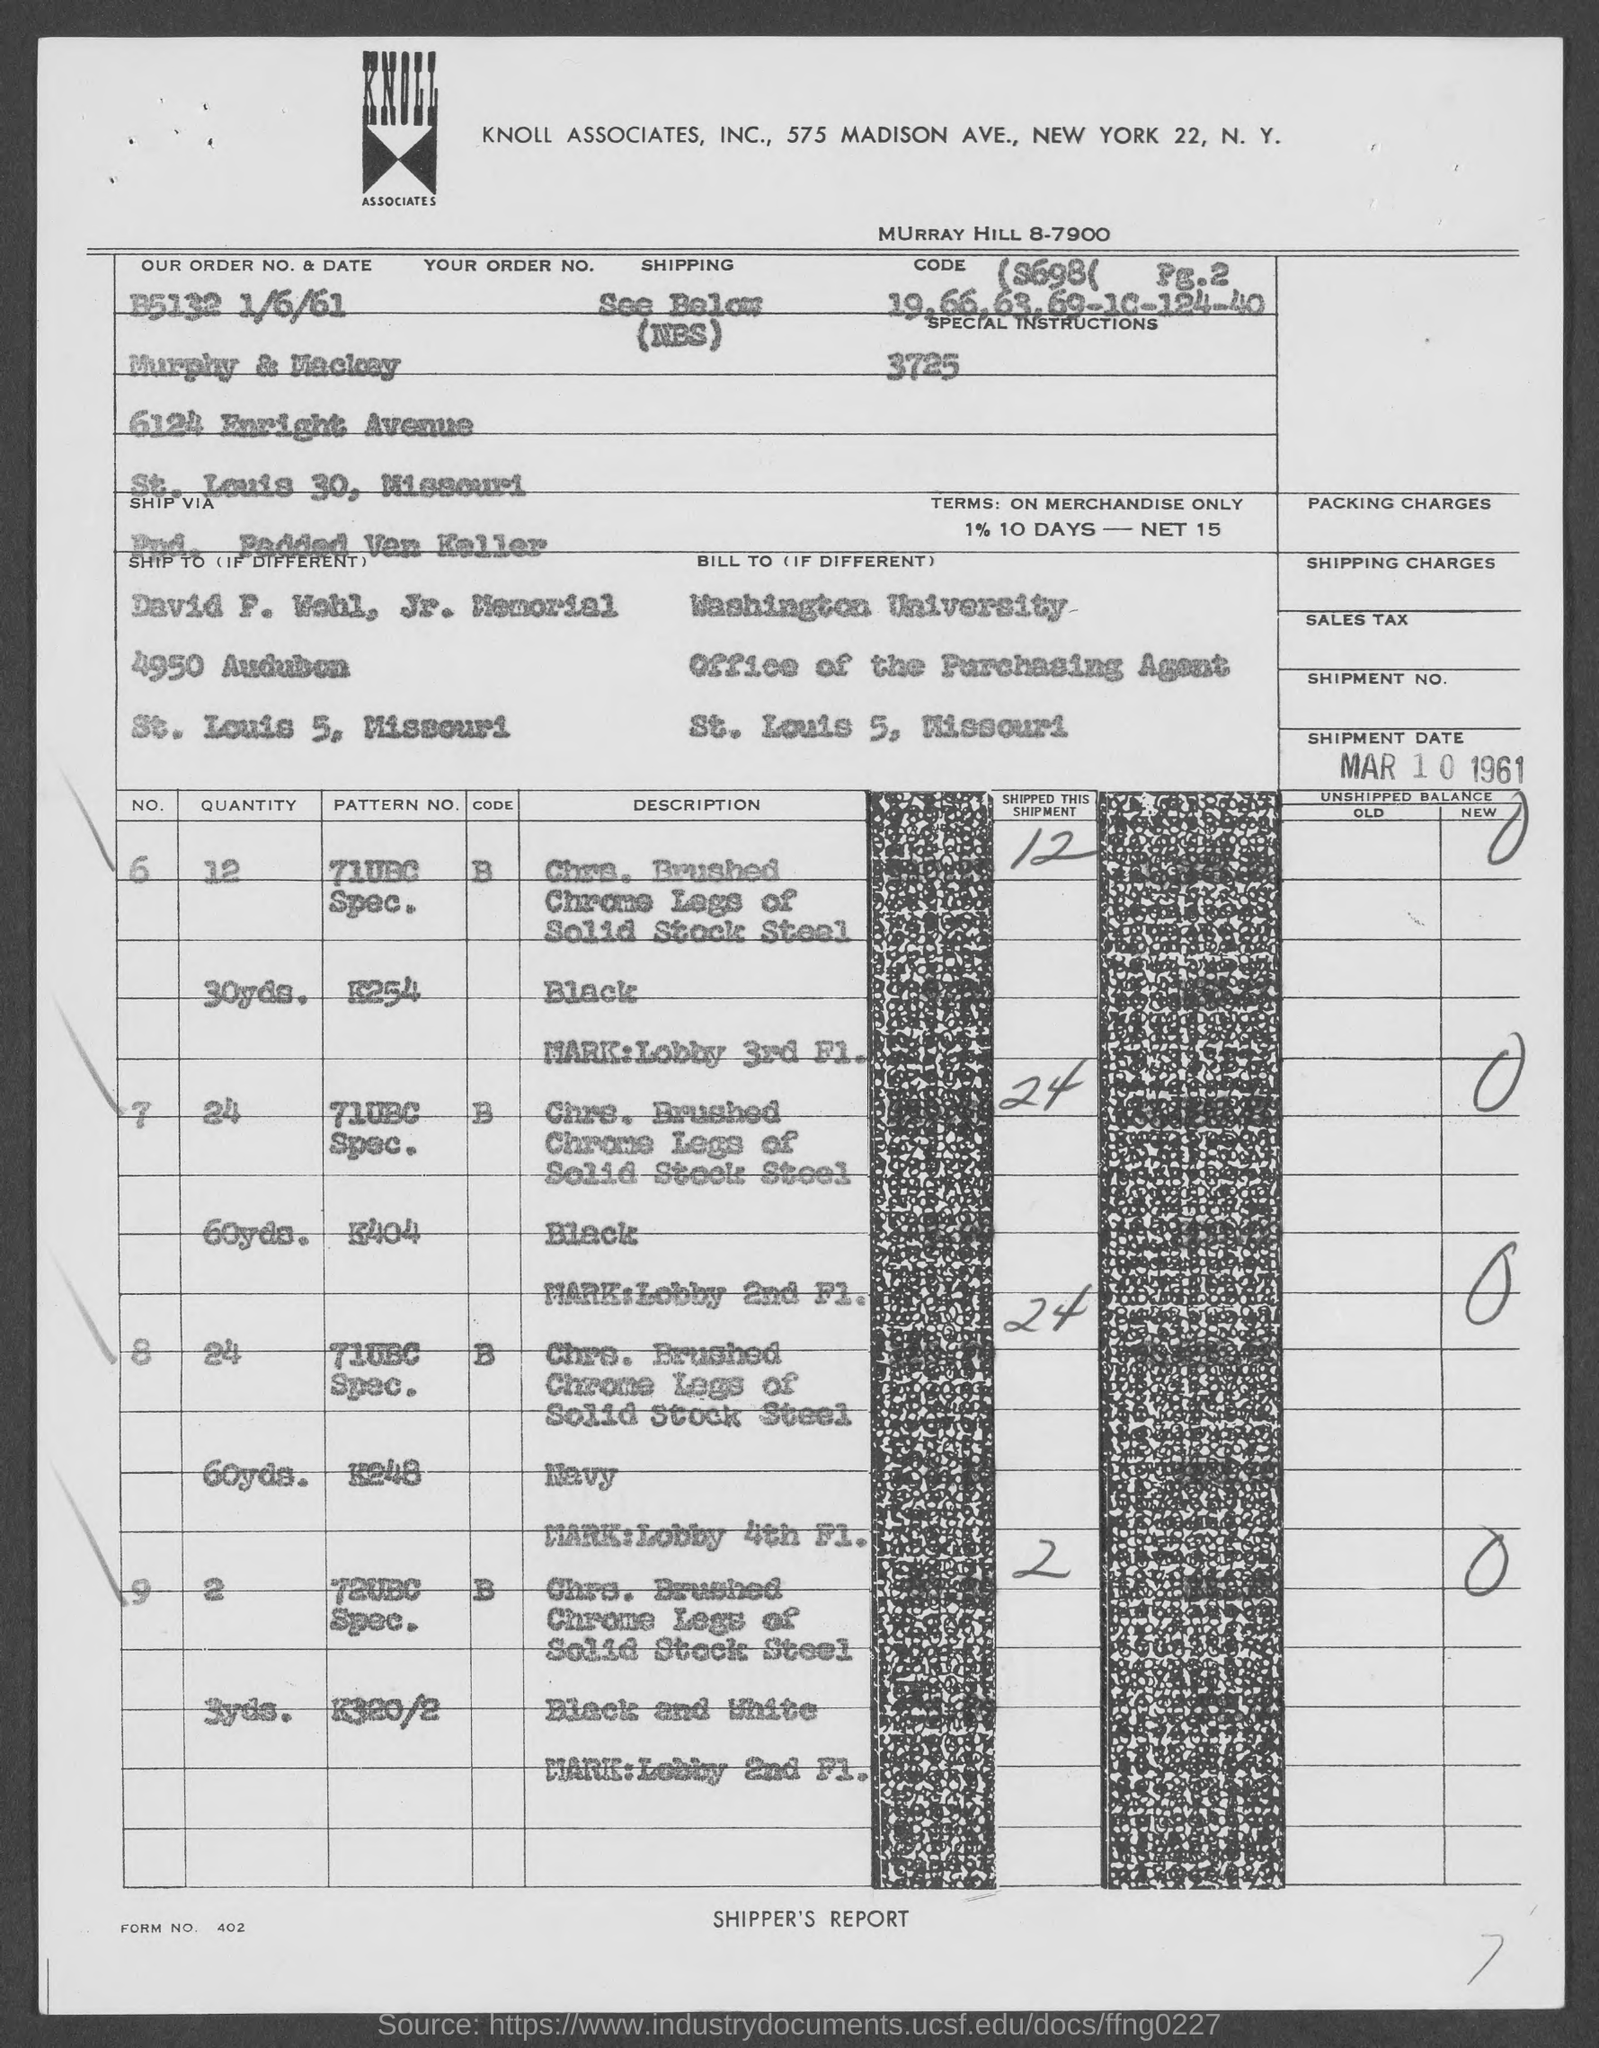Which company is mentioned in the header of the document?
Provide a short and direct response. Knoll Associates, Inc. What is the Order No. & date mentioned in the dcoument?
Keep it short and to the point. B5132 1/6/61. What is the Shipment date given in the document?
Provide a short and direct response. Mar 10 1961. Which university is mentioned in the billing address?
Your answer should be very brief. Washington University. 